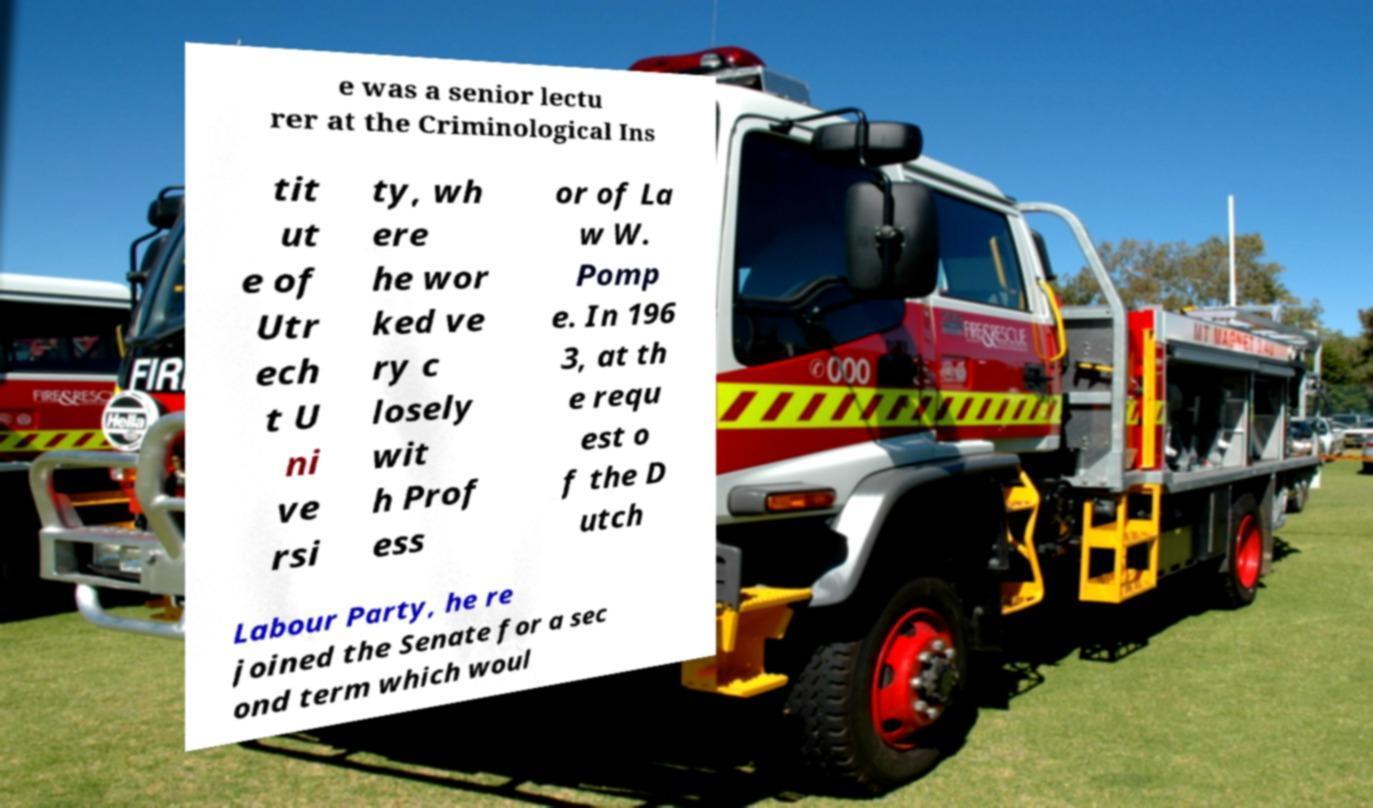Could you extract and type out the text from this image? e was a senior lectu rer at the Criminological Ins tit ut e of Utr ech t U ni ve rsi ty, wh ere he wor ked ve ry c losely wit h Prof ess or of La w W. Pomp e. In 196 3, at th e requ est o f the D utch Labour Party, he re joined the Senate for a sec ond term which woul 